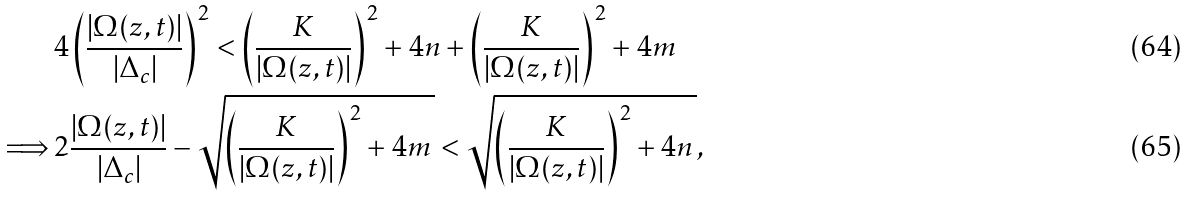Convert formula to latex. <formula><loc_0><loc_0><loc_500><loc_500>& 4 \left ( \frac { | \Omega ( z , t ) | } { | \Delta _ { c } | } \right ) ^ { 2 } < \left ( \frac { K } { | \Omega ( z , t ) | } \right ) ^ { 2 } + 4 n + \left ( \frac { K } { | \Omega ( z , t ) | } \right ) ^ { 2 } + 4 m \\ \Longrightarrow \, & 2 \frac { | \Omega ( z , t ) | } { | \Delta _ { c } | } - \sqrt { \left ( \frac { K } { | \Omega ( z , t ) | } \right ) ^ { 2 } + 4 m \, } < \sqrt { \left ( \frac { K } { | \Omega ( z , t ) | } \right ) ^ { 2 } + 4 n \, } ,</formula> 